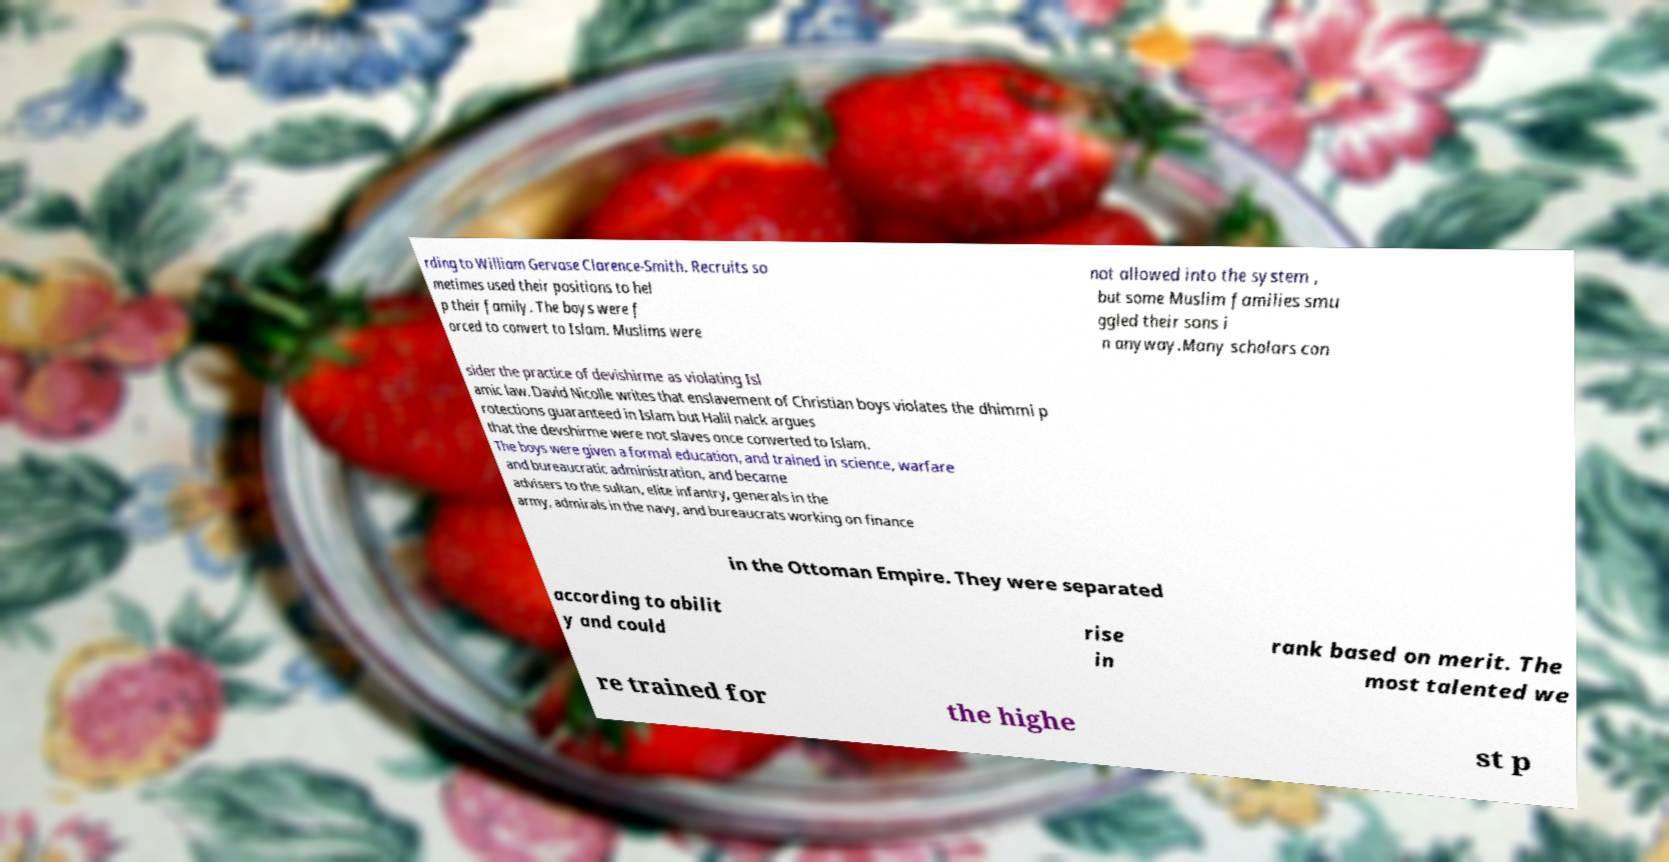For documentation purposes, I need the text within this image transcribed. Could you provide that? rding to William Gervase Clarence-Smith. Recruits so metimes used their positions to hel p their family. The boys were f orced to convert to Islam. Muslims were not allowed into the system , but some Muslim families smu ggled their sons i n anyway.Many scholars con sider the practice of devishirme as violating Isl amic law. David Nicolle writes that enslavement of Christian boys violates the dhimmi p rotections guaranteed in Islam but Halil nalck argues that the devshirme were not slaves once converted to Islam. The boys were given a formal education, and trained in science, warfare and bureaucratic administration, and became advisers to the sultan, elite infantry, generals in the army, admirals in the navy, and bureaucrats working on finance in the Ottoman Empire. They were separated according to abilit y and could rise in rank based on merit. The most talented we re trained for the highe st p 